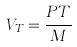Convert formula to latex. <formula><loc_0><loc_0><loc_500><loc_500>V _ { T } = \frac { P T } { M }</formula> 